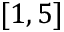<formula> <loc_0><loc_0><loc_500><loc_500>[ 1 , 5 ]</formula> 